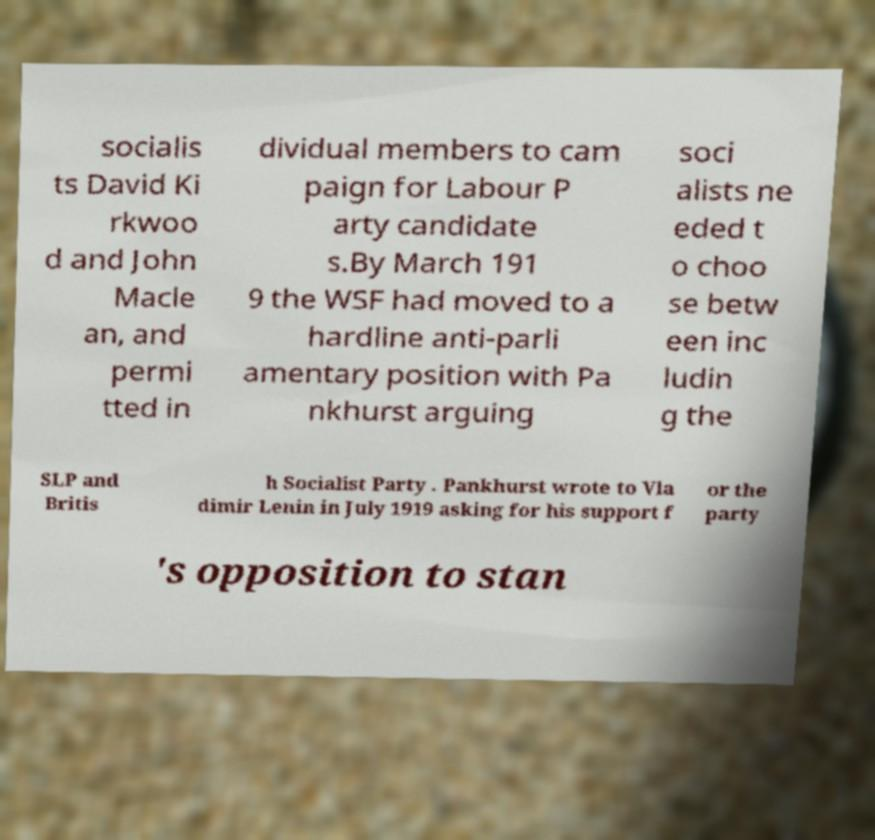Please read and relay the text visible in this image. What does it say? socialis ts David Ki rkwoo d and John Macle an, and permi tted in dividual members to cam paign for Labour P arty candidate s.By March 191 9 the WSF had moved to a hardline anti-parli amentary position with Pa nkhurst arguing soci alists ne eded t o choo se betw een inc ludin g the SLP and Britis h Socialist Party . Pankhurst wrote to Vla dimir Lenin in July 1919 asking for his support f or the party 's opposition to stan 